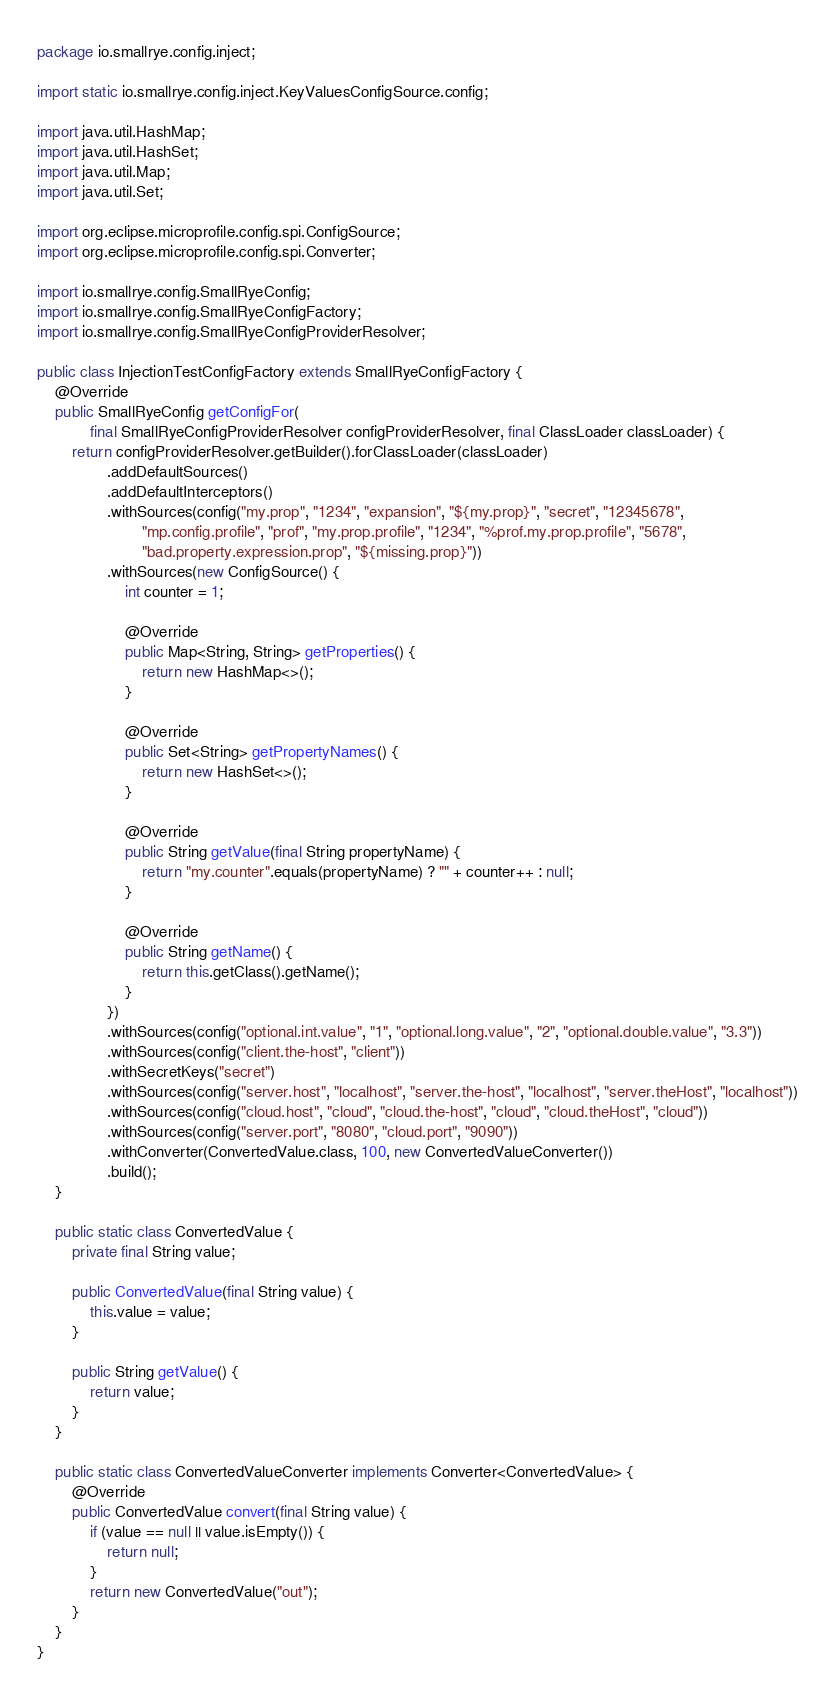<code> <loc_0><loc_0><loc_500><loc_500><_Java_>package io.smallrye.config.inject;

import static io.smallrye.config.inject.KeyValuesConfigSource.config;

import java.util.HashMap;
import java.util.HashSet;
import java.util.Map;
import java.util.Set;

import org.eclipse.microprofile.config.spi.ConfigSource;
import org.eclipse.microprofile.config.spi.Converter;

import io.smallrye.config.SmallRyeConfig;
import io.smallrye.config.SmallRyeConfigFactory;
import io.smallrye.config.SmallRyeConfigProviderResolver;

public class InjectionTestConfigFactory extends SmallRyeConfigFactory {
    @Override
    public SmallRyeConfig getConfigFor(
            final SmallRyeConfigProviderResolver configProviderResolver, final ClassLoader classLoader) {
        return configProviderResolver.getBuilder().forClassLoader(classLoader)
                .addDefaultSources()
                .addDefaultInterceptors()
                .withSources(config("my.prop", "1234", "expansion", "${my.prop}", "secret", "12345678",
                        "mp.config.profile", "prof", "my.prop.profile", "1234", "%prof.my.prop.profile", "5678",
                        "bad.property.expression.prop", "${missing.prop}"))
                .withSources(new ConfigSource() {
                    int counter = 1;

                    @Override
                    public Map<String, String> getProperties() {
                        return new HashMap<>();
                    }

                    @Override
                    public Set<String> getPropertyNames() {
                        return new HashSet<>();
                    }

                    @Override
                    public String getValue(final String propertyName) {
                        return "my.counter".equals(propertyName) ? "" + counter++ : null;
                    }

                    @Override
                    public String getName() {
                        return this.getClass().getName();
                    }
                })
                .withSources(config("optional.int.value", "1", "optional.long.value", "2", "optional.double.value", "3.3"))
                .withSources(config("client.the-host", "client"))
                .withSecretKeys("secret")
                .withSources(config("server.host", "localhost", "server.the-host", "localhost", "server.theHost", "localhost"))
                .withSources(config("cloud.host", "cloud", "cloud.the-host", "cloud", "cloud.theHost", "cloud"))
                .withSources(config("server.port", "8080", "cloud.port", "9090"))
                .withConverter(ConvertedValue.class, 100, new ConvertedValueConverter())
                .build();
    }

    public static class ConvertedValue {
        private final String value;

        public ConvertedValue(final String value) {
            this.value = value;
        }

        public String getValue() {
            return value;
        }
    }

    public static class ConvertedValueConverter implements Converter<ConvertedValue> {
        @Override
        public ConvertedValue convert(final String value) {
            if (value == null || value.isEmpty()) {
                return null;
            }
            return new ConvertedValue("out");
        }
    }
}
</code> 